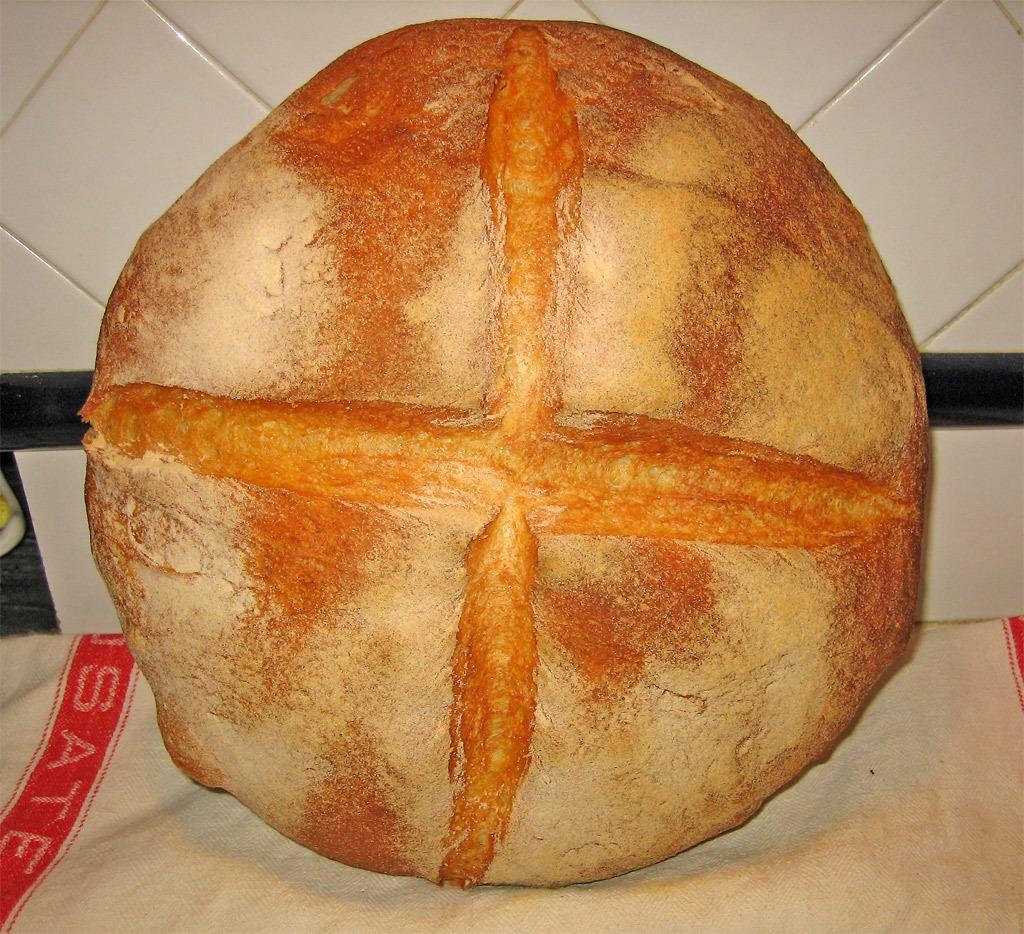What is the main subject of the image? There is an object in the image. Can you describe the object's placement? The object is on a cloth. What can be seen in the background of the image? There is a wall in the background of the image. How many fish are swimming near the object in the image? There are no fish present in the image. Did the earthquake cause any damage to the object in the image? There is no mention of an earthquake or any damage to the object in the image. 